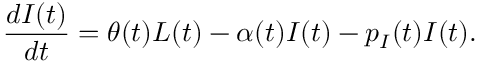<formula> <loc_0><loc_0><loc_500><loc_500>\frac { d I ( t ) } { d t } = \theta ( t ) L ( t ) - \alpha ( t ) I ( t ) - p _ { I } ( t ) I ( t ) .</formula> 